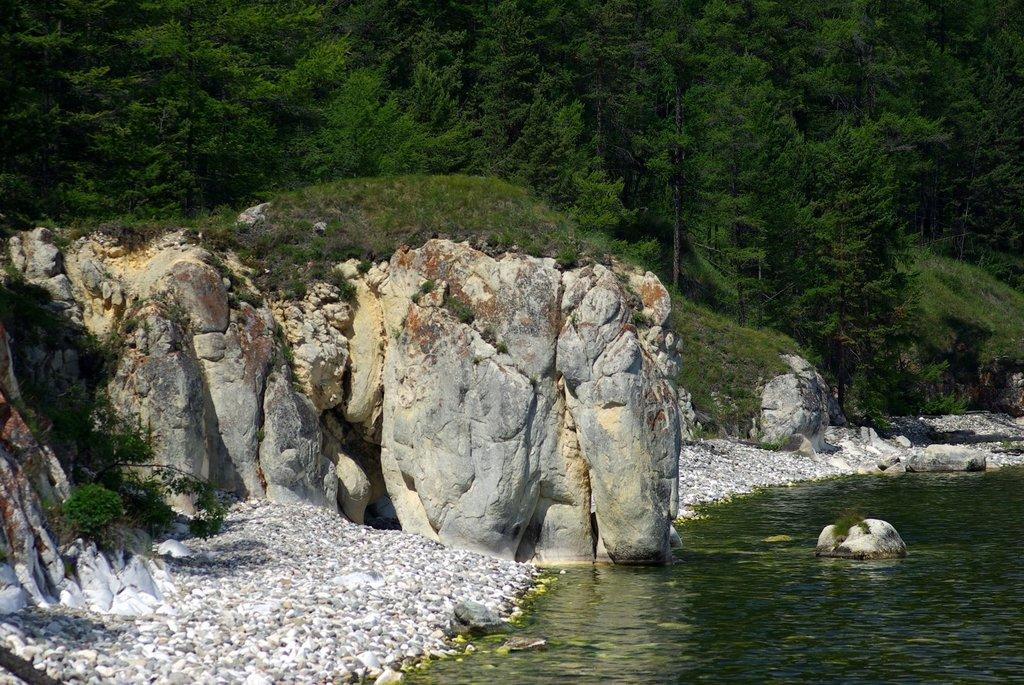What can be found on the left side of the image? There are stones on the left side of the image. What is located on the right side of the image? There is water on the right side of the image. What type of vegetation is visible at the top of the image? There are green trees visible at the top of the image. Can you see a clam playing chess in the image? There is no clam or chess game present in the image. Is there anyone walking in the image? The image does not show any people or animals walking; it primarily features stones, water, and trees. 